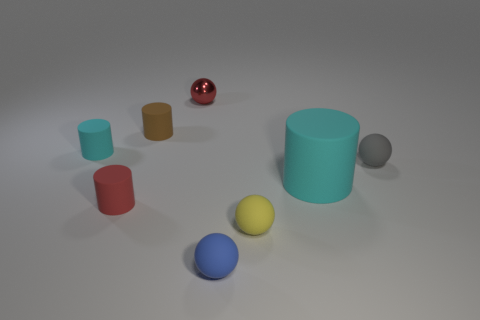Are there any other things that have the same material as the red ball?
Keep it short and to the point. No. The small matte thing that is the same color as the big cylinder is what shape?
Make the answer very short. Cylinder. What number of things are big things or rubber objects that are on the left side of the big cylinder?
Your answer should be very brief. 6. Does the ball behind the gray rubber ball have the same color as the large rubber thing?
Give a very brief answer. No. Is the number of blue spheres on the left side of the brown cylinder greater than the number of blue objects that are right of the blue matte thing?
Ensure brevity in your answer.  No. Is there any other thing of the same color as the shiny thing?
Ensure brevity in your answer.  Yes. What number of objects are small cyan rubber cylinders or cyan cylinders?
Provide a short and direct response. 2. Does the yellow ball that is right of the brown cylinder have the same size as the red matte cylinder?
Ensure brevity in your answer.  Yes. What number of other objects are the same size as the red metallic object?
Make the answer very short. 6. Is there a cyan rubber thing?
Offer a terse response. Yes. 